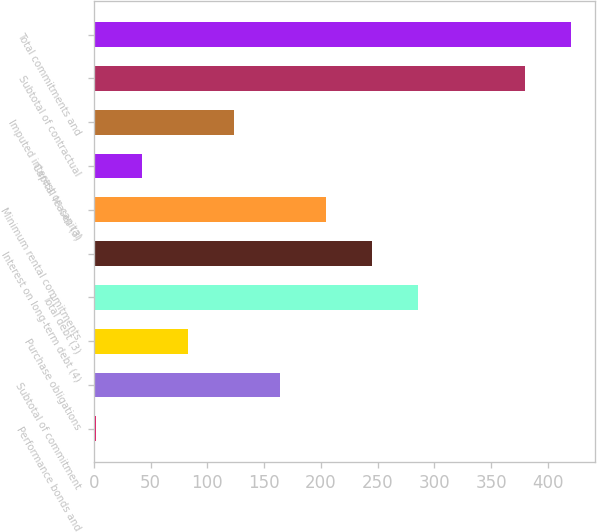Convert chart to OTSL. <chart><loc_0><loc_0><loc_500><loc_500><bar_chart><fcel>Performance bonds and<fcel>Subtotal of commitment<fcel>Purchase obligations<fcel>Total debt (3)<fcel>Interest on long-term debt (4)<fcel>Minimum rental commitments<fcel>Capital leases (3)<fcel>Imputed interest on capital<fcel>Subtotal of contractual<fcel>Total commitments and<nl><fcel>2<fcel>164<fcel>83<fcel>285.5<fcel>245<fcel>204.5<fcel>42.5<fcel>123.5<fcel>380<fcel>420.5<nl></chart> 